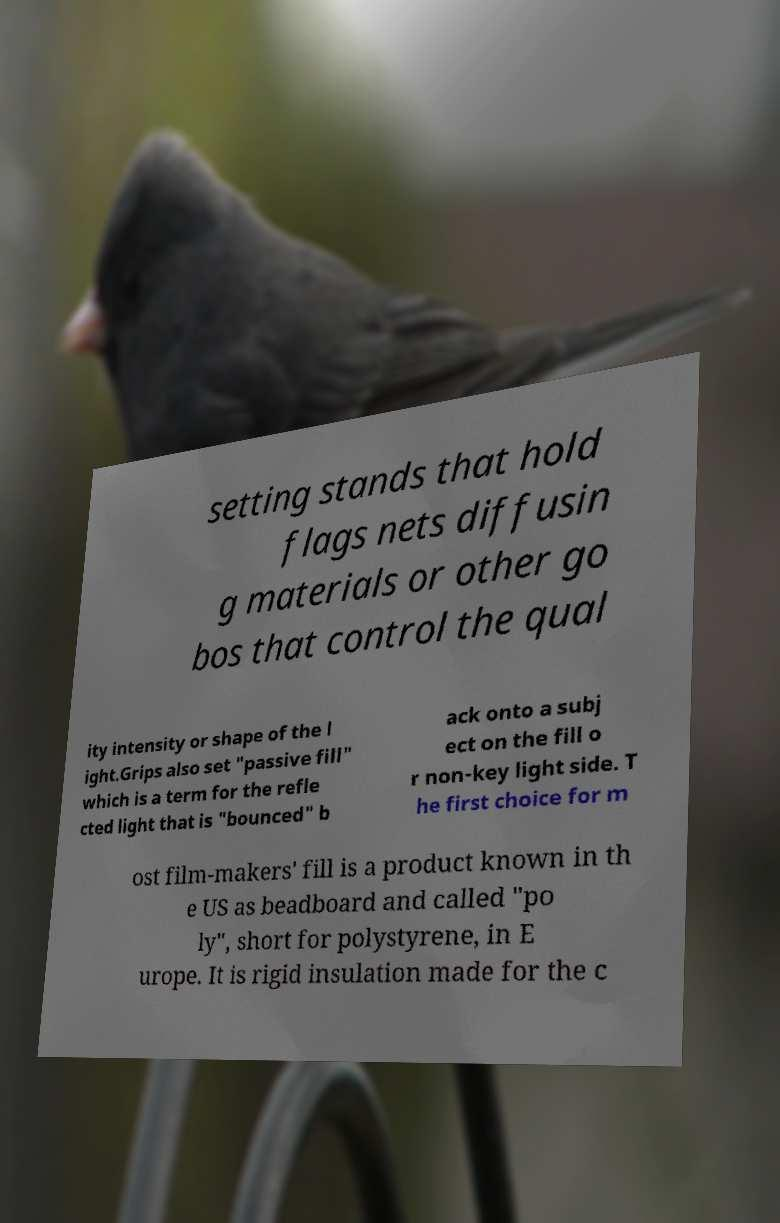What messages or text are displayed in this image? I need them in a readable, typed format. setting stands that hold flags nets diffusin g materials or other go bos that control the qual ity intensity or shape of the l ight.Grips also set "passive fill" which is a term for the refle cted light that is "bounced" b ack onto a subj ect on the fill o r non-key light side. T he first choice for m ost film-makers' fill is a product known in th e US as beadboard and called "po ly", short for polystyrene, in E urope. It is rigid insulation made for the c 